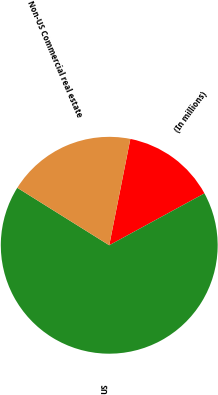<chart> <loc_0><loc_0><loc_500><loc_500><pie_chart><fcel>(In millions)<fcel>US<fcel>Non-US Commercial real estate<nl><fcel>13.94%<fcel>66.83%<fcel>19.23%<nl></chart> 